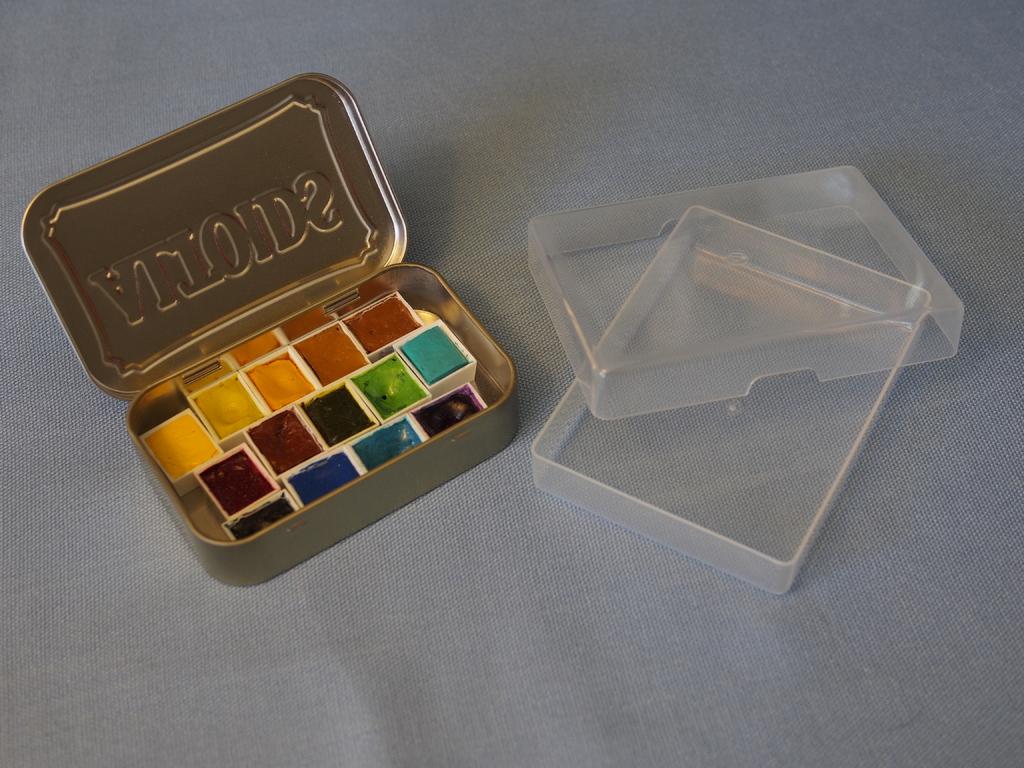What is the brand on the lid of the tin container?
Provide a short and direct response. Altoids. What was in this tin before it was used for paints?
Offer a terse response. Altoids. 